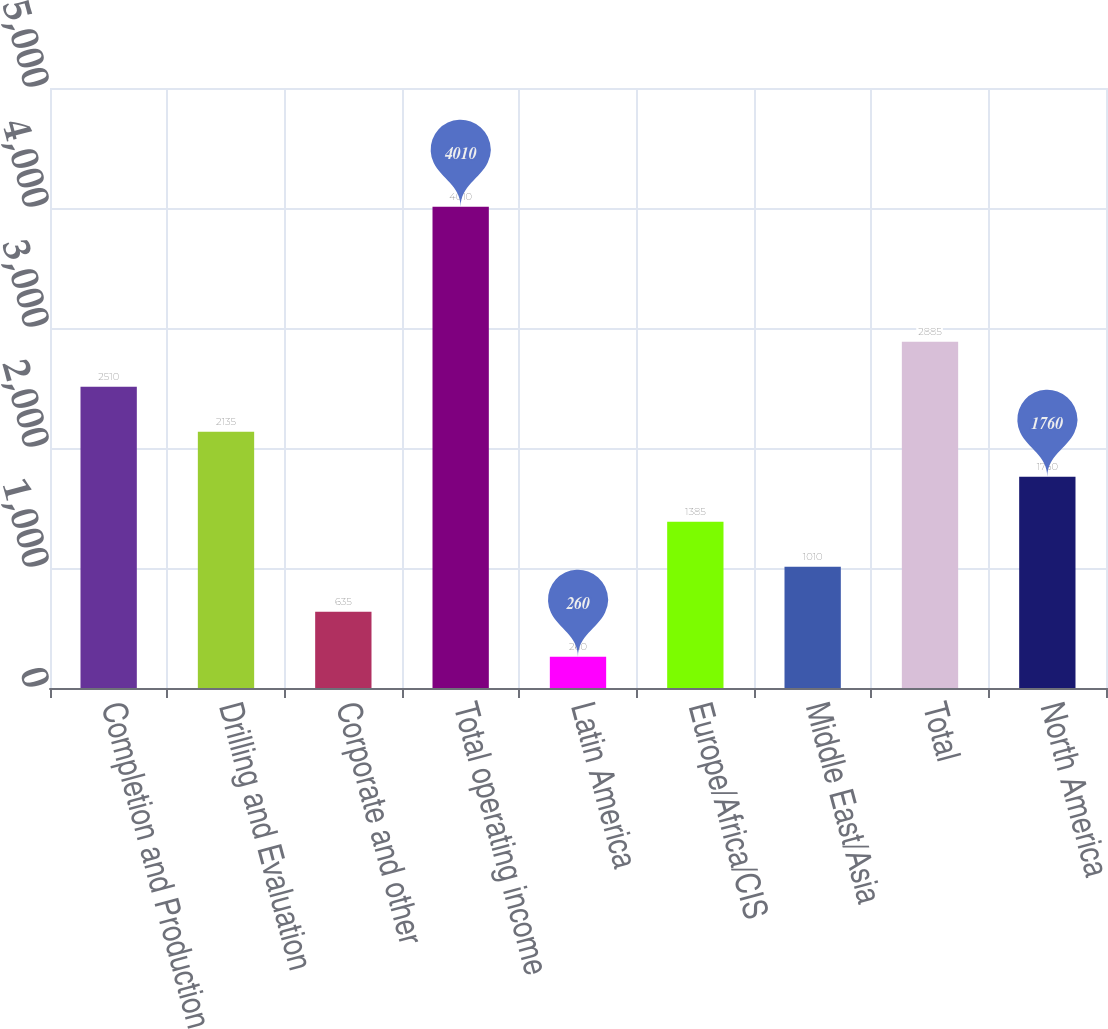Convert chart. <chart><loc_0><loc_0><loc_500><loc_500><bar_chart><fcel>Completion and Production<fcel>Drilling and Evaluation<fcel>Corporate and other<fcel>Total operating income<fcel>Latin America<fcel>Europe/Africa/CIS<fcel>Middle East/Asia<fcel>Total<fcel>North America<nl><fcel>2510<fcel>2135<fcel>635<fcel>4010<fcel>260<fcel>1385<fcel>1010<fcel>2885<fcel>1760<nl></chart> 